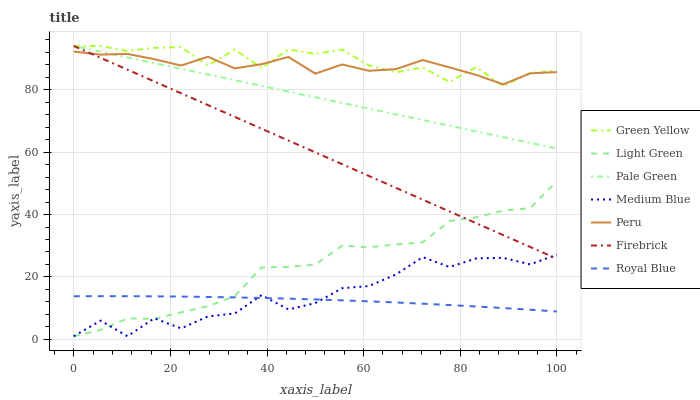Does Royal Blue have the minimum area under the curve?
Answer yes or no. Yes. Does Green Yellow have the maximum area under the curve?
Answer yes or no. Yes. Does Firebrick have the minimum area under the curve?
Answer yes or no. No. Does Firebrick have the maximum area under the curve?
Answer yes or no. No. Is Firebrick the smoothest?
Answer yes or no. Yes. Is Green Yellow the roughest?
Answer yes or no. Yes. Is Medium Blue the smoothest?
Answer yes or no. No. Is Medium Blue the roughest?
Answer yes or no. No. Does Light Green have the lowest value?
Answer yes or no. Yes. Does Firebrick have the lowest value?
Answer yes or no. No. Does Green Yellow have the highest value?
Answer yes or no. Yes. Does Medium Blue have the highest value?
Answer yes or no. No. Is Royal Blue less than Firebrick?
Answer yes or no. Yes. Is Firebrick greater than Royal Blue?
Answer yes or no. Yes. Does Light Green intersect Royal Blue?
Answer yes or no. Yes. Is Light Green less than Royal Blue?
Answer yes or no. No. Is Light Green greater than Royal Blue?
Answer yes or no. No. Does Royal Blue intersect Firebrick?
Answer yes or no. No. 